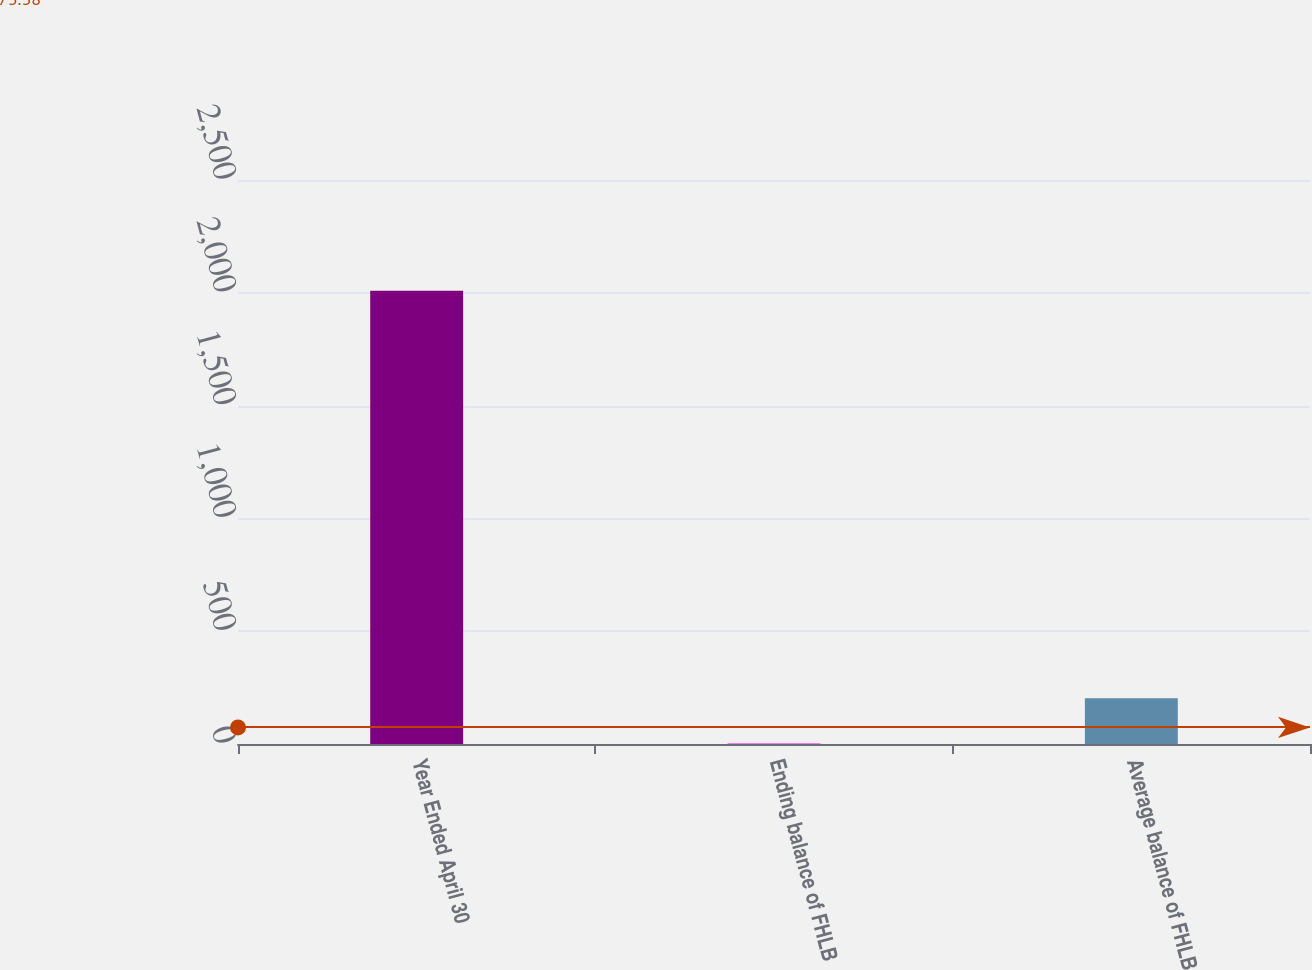<chart> <loc_0><loc_0><loc_500><loc_500><bar_chart><fcel>Year Ended April 30<fcel>Ending balance of FHLB<fcel>Average balance of FHLB<nl><fcel>2009<fcel>1.76<fcel>202.48<nl></chart> 